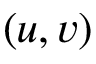<formula> <loc_0><loc_0><loc_500><loc_500>( u , v )</formula> 